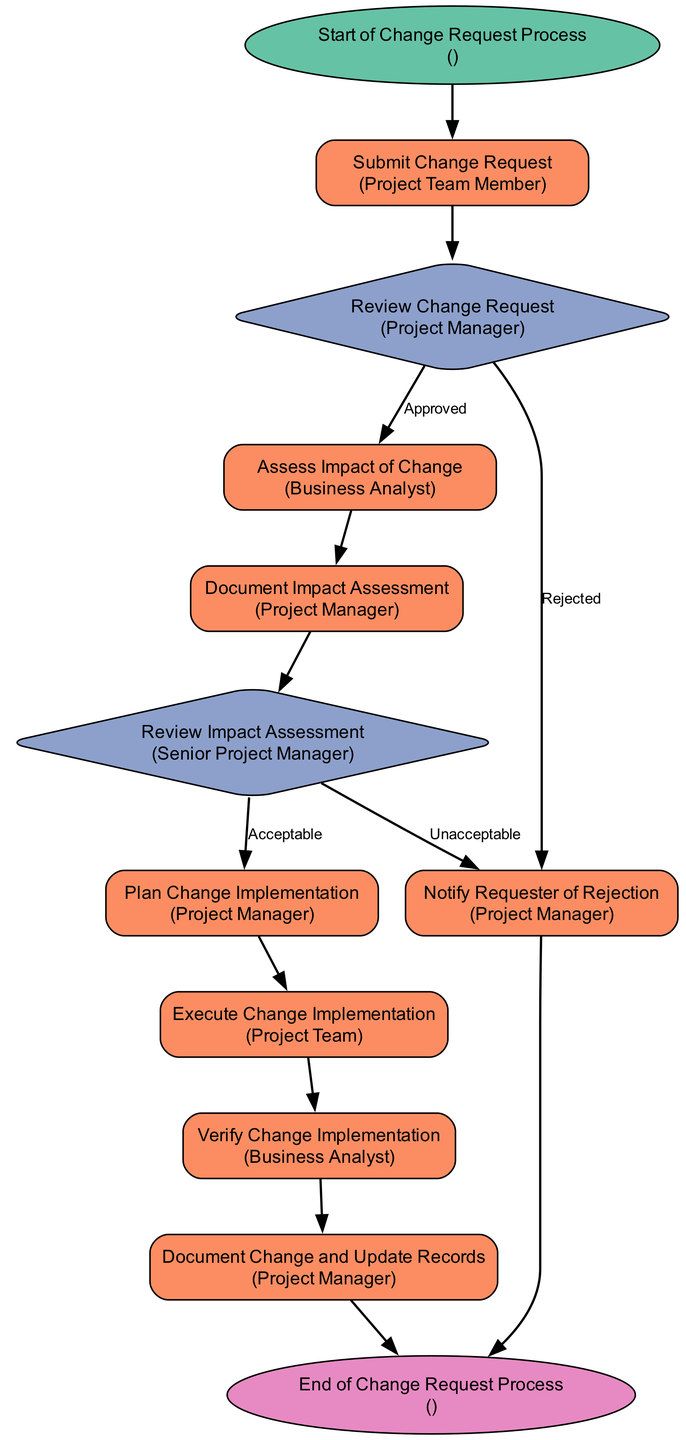What is the starting point of the change request process? The starting point is clearly defined in the diagram as "Start of Change Request Process," which is labeled at the initial node.
Answer: Start of Change Request Process How many decision points are there in the diagram? There are two decision points: "Review Change Request" and "Review Impact Assessment." These are represented in the diagram by diamond-shaped nodes.
Answer: 2 Who submits the change request? The diagram specifies that the "Project Team Member" is responsible for submitting the change request, indicated in the process node labeled "Submit Change Request."
Answer: Project Team Member What happens if a change request is rejected? According to the flowchart, if a change request is rejected, the next step is to "Notify Requester of Rejection," as indicated in the decision node options.
Answer: Notify Requester of Rejection What actor is responsible for assessing the impact of the change? The actor responsible for this step is the "Business Analyst," as shown in the process node labeled "Assess Impact of Change."
Answer: Business Analyst What is the outcome if the impact assessment is deemed unacceptable? If the impact assessment is "Unacceptable," it leads to the same node as the rejection of the change request, thus resulting in "Notify Requester of Rejection."
Answer: Notify Requester of Rejection After planning the change implementation, what is the next step? The next step after "Plan Change Implementation" is to "Execute Change Implementation," as indicated by the directed edge connecting these two process nodes in the flowchart.
Answer: Execute Change Implementation How does the process conclude after documenting the change? The process concludes at the "End of Change Request Process," which is clearly marked as the final node in the diagram.
Answer: End of Change Request Process 